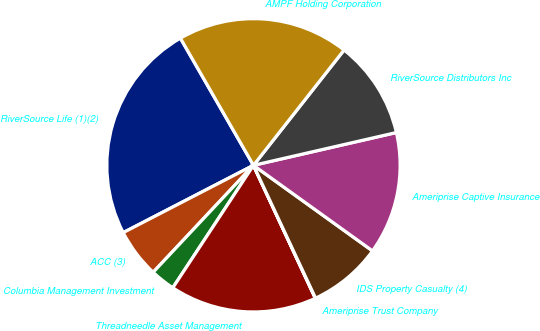<chart> <loc_0><loc_0><loc_500><loc_500><pie_chart><fcel>RiverSource Life (1)(2)<fcel>ACC (3)<fcel>Columbia Management Investment<fcel>Threadneedle Asset Management<fcel>Ameriprise Trust Company<fcel>IDS Property Casualty (4)<fcel>Ameriprise Captive Insurance<fcel>RiverSource Distributors Inc<fcel>AMPF Holding Corporation<nl><fcel>24.29%<fcel>5.42%<fcel>2.72%<fcel>16.2%<fcel>0.03%<fcel>8.12%<fcel>13.51%<fcel>10.81%<fcel>18.9%<nl></chart> 